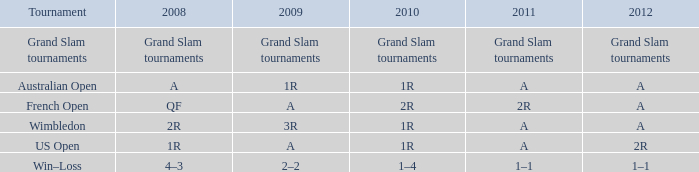Name the 2010 for 2011 of a and 2008 of 1r 1R. 